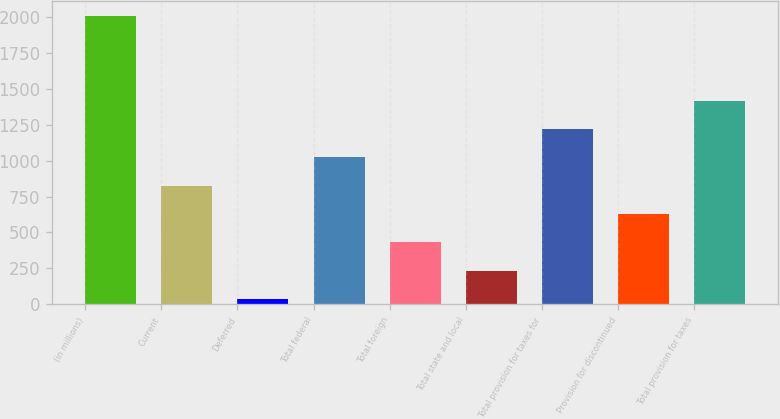Convert chart to OTSL. <chart><loc_0><loc_0><loc_500><loc_500><bar_chart><fcel>(in millions)<fcel>Current<fcel>Deferred<fcel>Total federal<fcel>Total foreign<fcel>Total state and local<fcel>Total provision for taxes for<fcel>Provision for discontinued<fcel>Total provision for taxes<nl><fcel>2010<fcel>826.2<fcel>37<fcel>1023.5<fcel>431.6<fcel>234.3<fcel>1220.8<fcel>628.9<fcel>1418.1<nl></chart> 